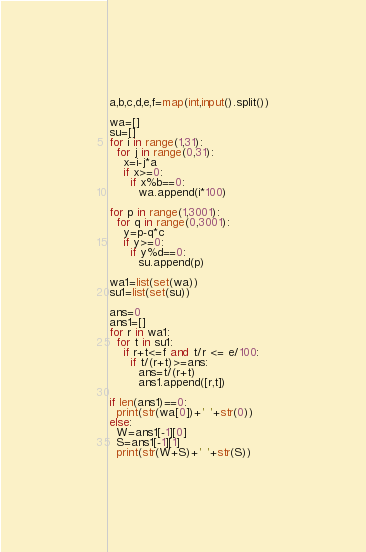<code> <loc_0><loc_0><loc_500><loc_500><_Python_>a,b,c,d,e,f=map(int,input().split())

wa=[]
su=[]
for i in range(1,31):
  for j in range(0,31):
    x=i-j*a
    if x>=0:
      if x%b==0:
        wa.append(i*100)
        
for p in range(1,3001):
  for q in range(0,3001):
    y=p-q*c
    if y>=0:
      if y%d==0:
        su.append(p)
        
wa1=list(set(wa))
su1=list(set(su))

ans=0
ans1=[]
for r in wa1:
  for t in su1:
    if r+t<=f and t/r <= e/100:
      if t/(r+t)>=ans:
        ans=t/(r+t)
        ans1.append([r,t])
        
if len(ans1)==0:
  print(str(wa[0])+' '+str(0))
else:
  W=ans1[-1][0]
  S=ans1[-1][1]
  print(str(W+S)+' '+str(S))</code> 